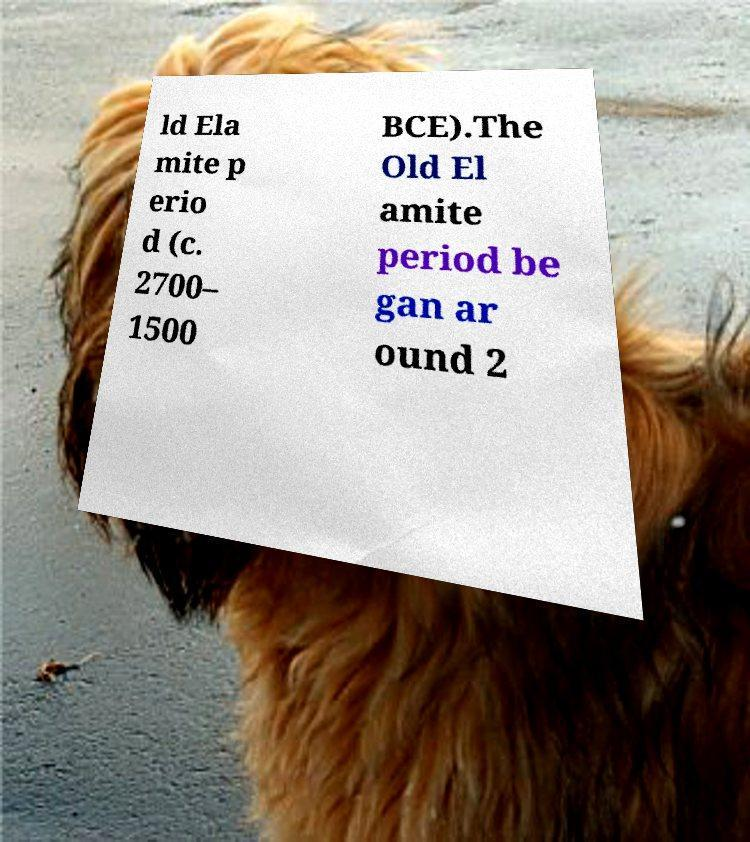Could you extract and type out the text from this image? ld Ela mite p erio d (c. 2700– 1500 BCE).The Old El amite period be gan ar ound 2 